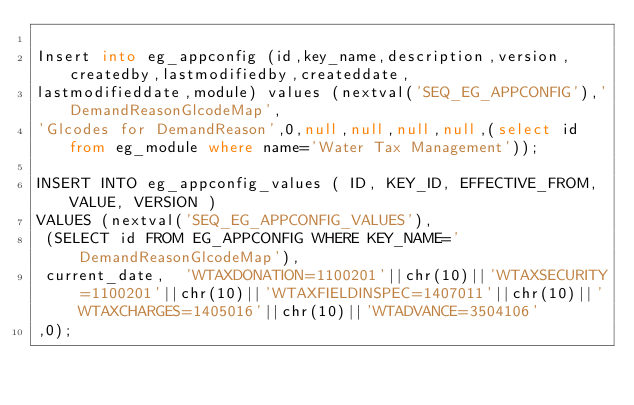<code> <loc_0><loc_0><loc_500><loc_500><_SQL_>
Insert into eg_appconfig (id,key_name,description,version,createdby,lastmodifiedby,createddate,
lastmodifieddate,module) values (nextval('SEQ_EG_APPCONFIG'),'DemandReasonGlcodeMap',
'Glcodes for DemandReason',0,null,null,null,null,(select id from eg_module where name='Water Tax Management'));

INSERT INTO eg_appconfig_values ( ID, KEY_ID, EFFECTIVE_FROM, VALUE, VERSION ) 
VALUES (nextval('SEQ_EG_APPCONFIG_VALUES'),
 (SELECT id FROM EG_APPCONFIG WHERE KEY_NAME='DemandReasonGlcodeMap'),
 current_date,  'WTAXDONATION=1100201'||chr(10)||'WTAXSECURITY=1100201'||chr(10)||'WTAXFIELDINSPEC=1407011'||chr(10)||'WTAXCHARGES=1405016'||chr(10)||'WTADVANCE=3504106'
,0);</code> 